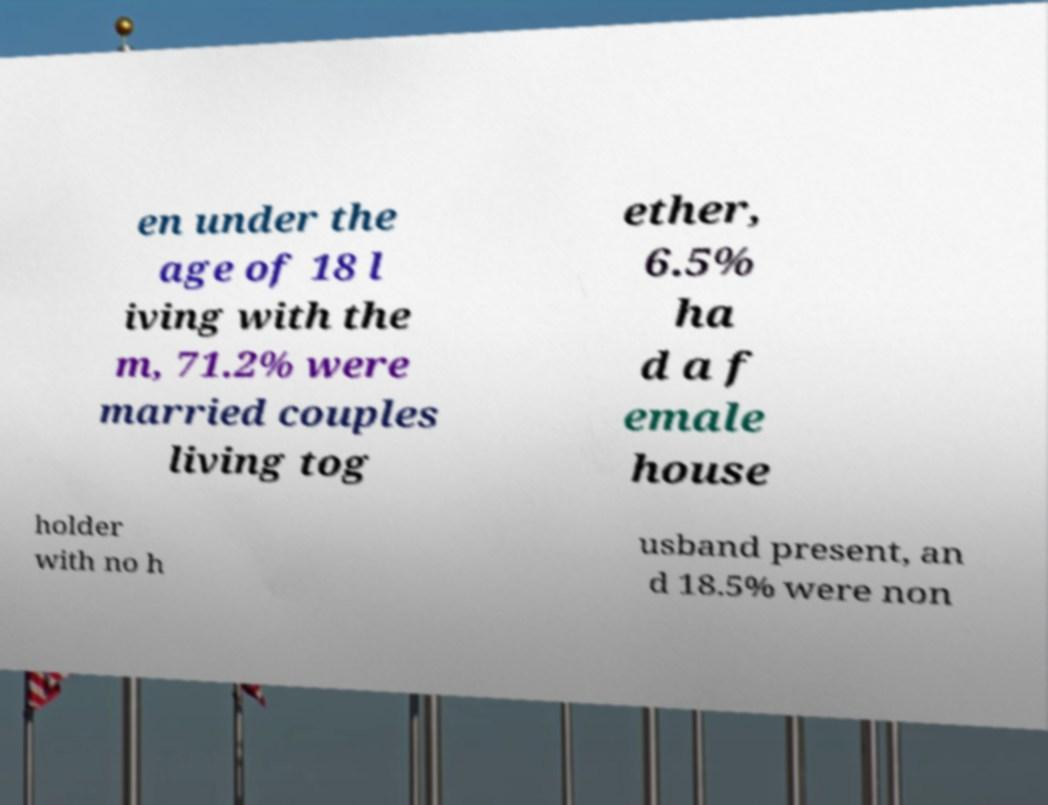Can you read and provide the text displayed in the image?This photo seems to have some interesting text. Can you extract and type it out for me? en under the age of 18 l iving with the m, 71.2% were married couples living tog ether, 6.5% ha d a f emale house holder with no h usband present, an d 18.5% were non 